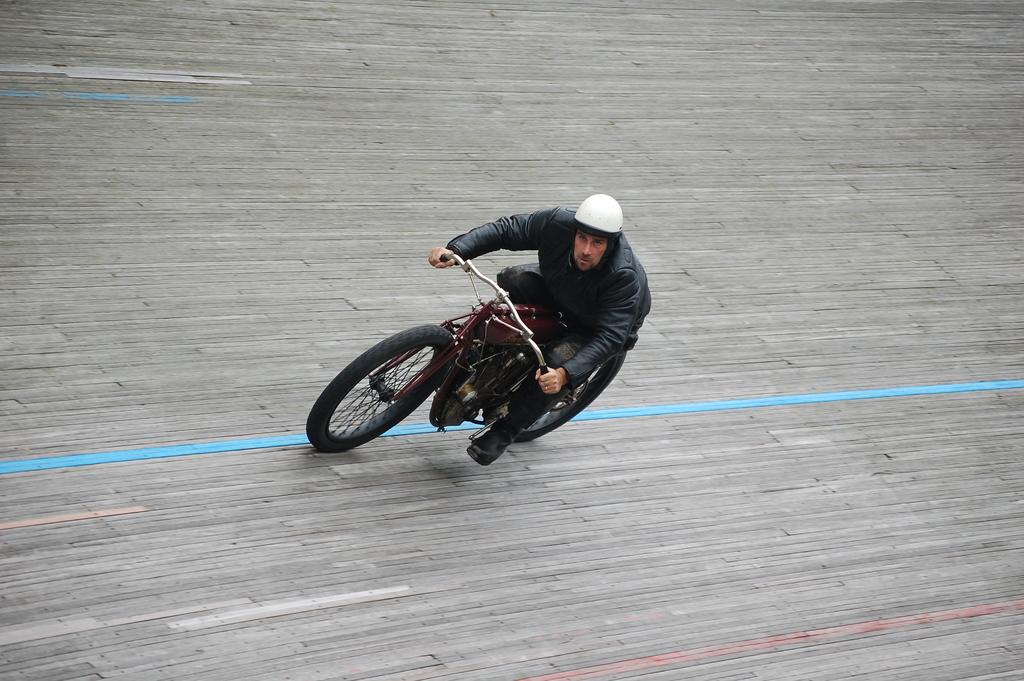Who is present in the image? There is a man in the image. What is the man doing in the image? The man is sitting on a vehicle. What type of clothing is the man wearing? The man is wearing a jacket. What type of headgear is the man wearing? The man is wearing a white color helmet. What channel is the man watching on the vehicle's screen? There is no screen or channel mentioned in the image; the man is simply sitting on a vehicle. 